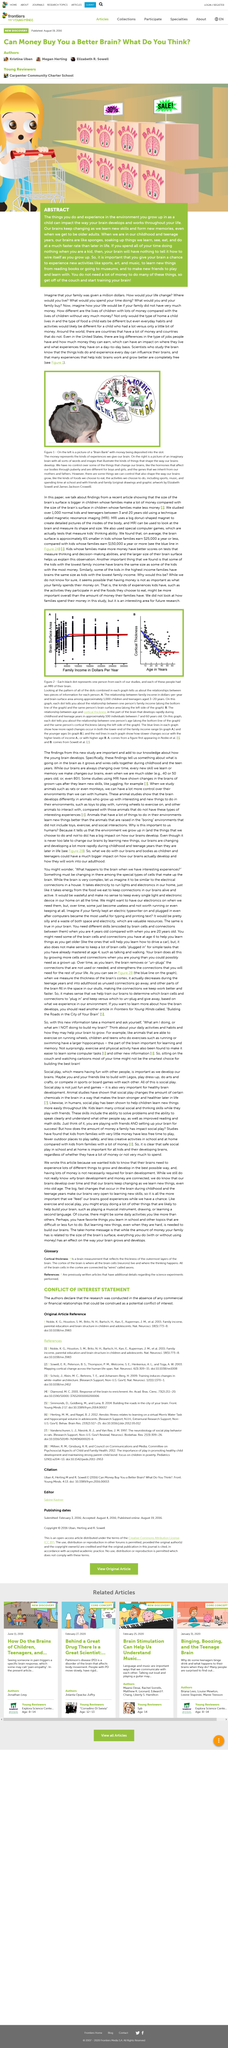Mention a couple of crucial points in this snapshot. Studies have shown that children from families with incomes of $25,000 have brains that are on average six percent smaller than the brains of children from families with $150,000 plus yearly incomes. The original drawings and graphic artwork belongs to Elizabeth Sowell and James Jackson Crowell. MRIs are large, donut-shaped magnets that are used to create detailed images of the internal structures of the body, including the brain. These images are used to diagnose and monitor a wide range of medical conditions, and they can also be used to measure the shape and size of the brain. One way to study the size of children's brains is by using an MRI, or magnetic resonance imaging. Researchers have previously conducted this study to gain insight into the development of children's brains. The picture depicts a "Brain Bank". 